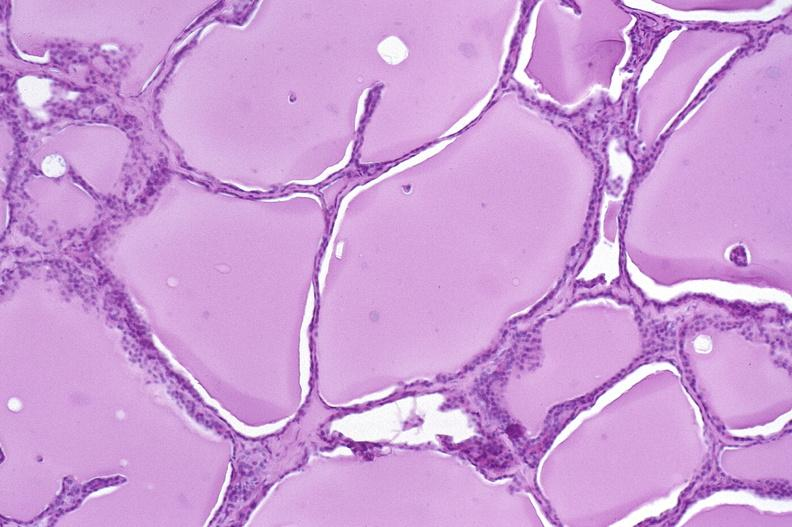where is this part in the figure?
Answer the question using a single word or phrase. Endocrine system 